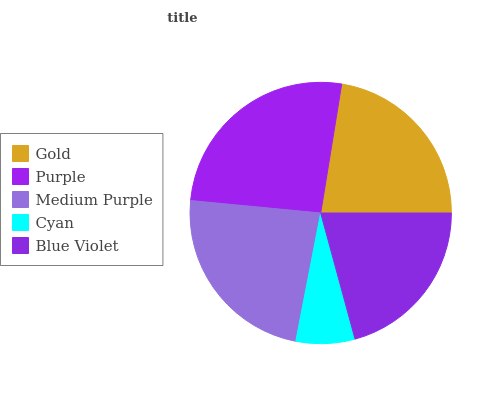Is Cyan the minimum?
Answer yes or no. Yes. Is Purple the maximum?
Answer yes or no. Yes. Is Medium Purple the minimum?
Answer yes or no. No. Is Medium Purple the maximum?
Answer yes or no. No. Is Purple greater than Medium Purple?
Answer yes or no. Yes. Is Medium Purple less than Purple?
Answer yes or no. Yes. Is Medium Purple greater than Purple?
Answer yes or no. No. Is Purple less than Medium Purple?
Answer yes or no. No. Is Gold the high median?
Answer yes or no. Yes. Is Gold the low median?
Answer yes or no. Yes. Is Medium Purple the high median?
Answer yes or no. No. Is Blue Violet the low median?
Answer yes or no. No. 